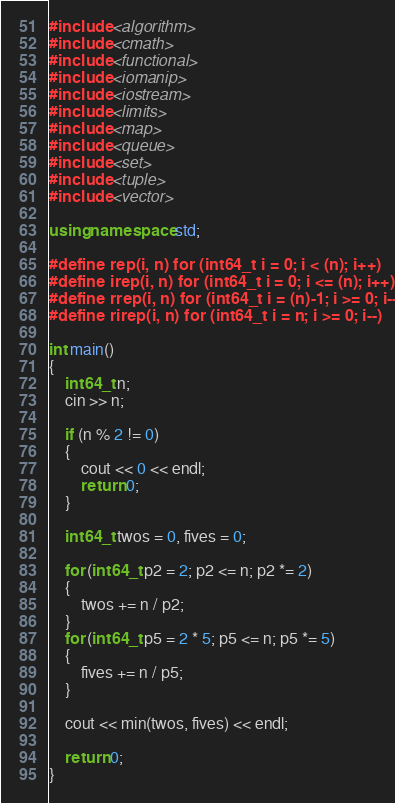Convert code to text. <code><loc_0><loc_0><loc_500><loc_500><_C++_>#include <algorithm>
#include <cmath>
#include <functional>
#include <iomanip>
#include <iostream>
#include <limits>
#include <map>
#include <queue>
#include <set>
#include <tuple>
#include <vector>

using namespace std;

#define rep(i, n) for (int64_t i = 0; i < (n); i++)
#define irep(i, n) for (int64_t i = 0; i <= (n); i++)
#define rrep(i, n) for (int64_t i = (n)-1; i >= 0; i--)
#define rirep(i, n) for (int64_t i = n; i >= 0; i--)

int main()
{
    int64_t n;
    cin >> n;

    if (n % 2 != 0)
    {
        cout << 0 << endl;
        return 0;
    }

    int64_t twos = 0, fives = 0;

    for (int64_t p2 = 2; p2 <= n; p2 *= 2)
    {
        twos += n / p2;
    }
    for (int64_t p5 = 2 * 5; p5 <= n; p5 *= 5)
    {
        fives += n / p5;
    }

    cout << min(twos, fives) << endl;

    return 0;
}</code> 